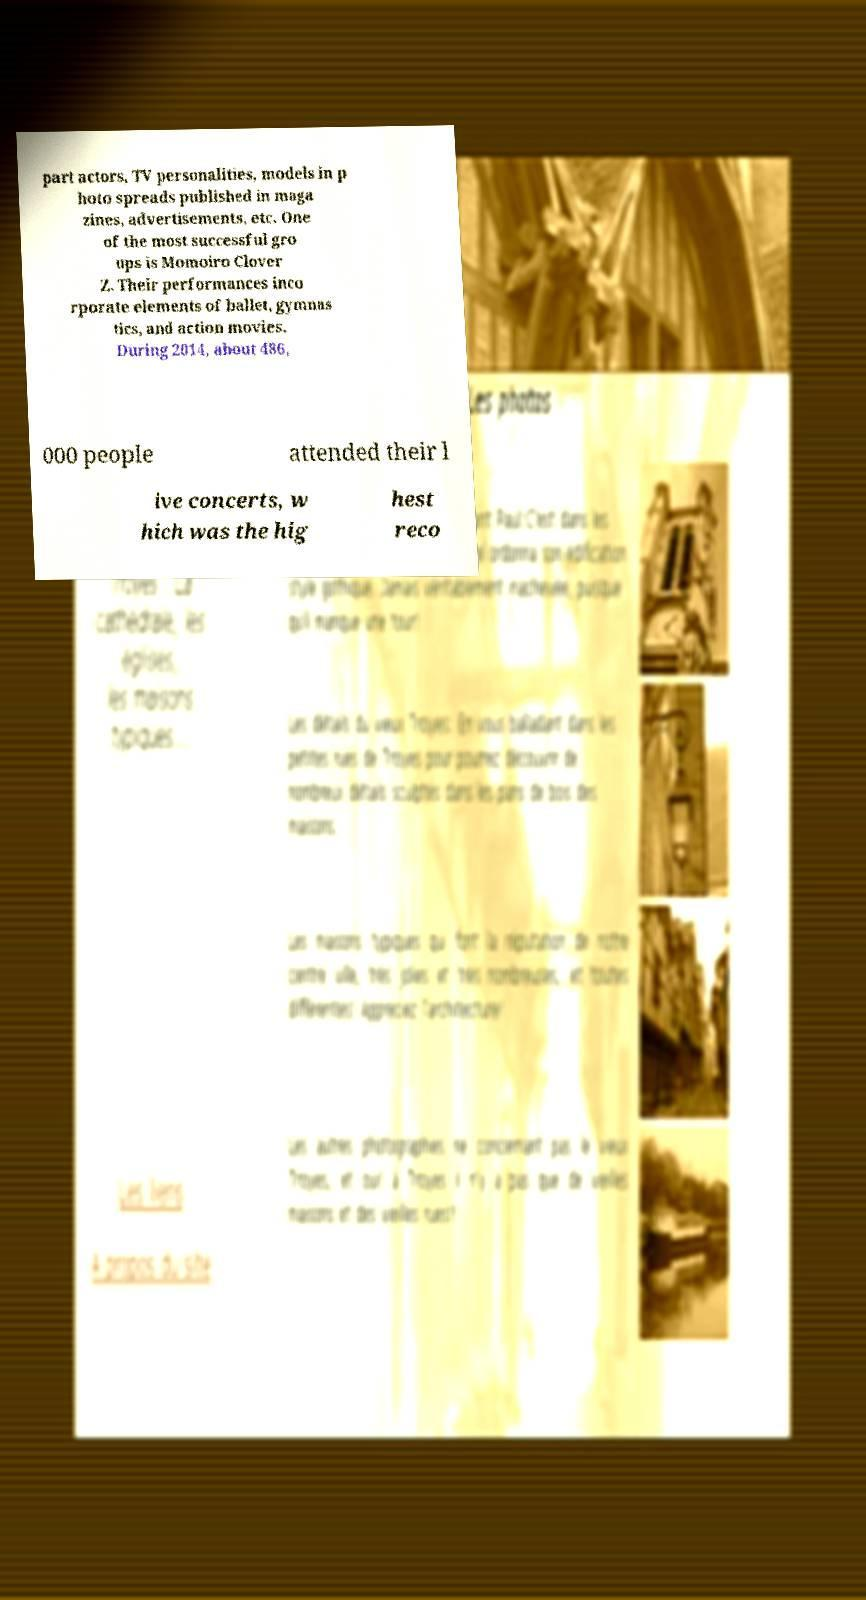Can you read and provide the text displayed in the image?This photo seems to have some interesting text. Can you extract and type it out for me? part actors, TV personalities, models in p hoto spreads published in maga zines, advertisements, etc. One of the most successful gro ups is Momoiro Clover Z. Their performances inco rporate elements of ballet, gymnas tics, and action movies. During 2014, about 486, 000 people attended their l ive concerts, w hich was the hig hest reco 